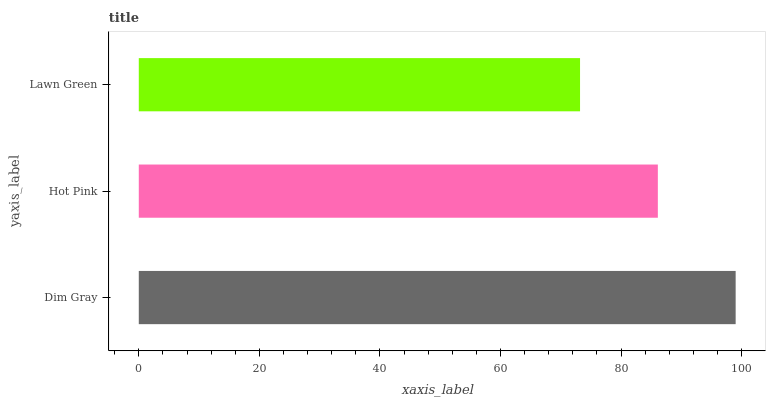Is Lawn Green the minimum?
Answer yes or no. Yes. Is Dim Gray the maximum?
Answer yes or no. Yes. Is Hot Pink the minimum?
Answer yes or no. No. Is Hot Pink the maximum?
Answer yes or no. No. Is Dim Gray greater than Hot Pink?
Answer yes or no. Yes. Is Hot Pink less than Dim Gray?
Answer yes or no. Yes. Is Hot Pink greater than Dim Gray?
Answer yes or no. No. Is Dim Gray less than Hot Pink?
Answer yes or no. No. Is Hot Pink the high median?
Answer yes or no. Yes. Is Hot Pink the low median?
Answer yes or no. Yes. Is Dim Gray the high median?
Answer yes or no. No. Is Lawn Green the low median?
Answer yes or no. No. 